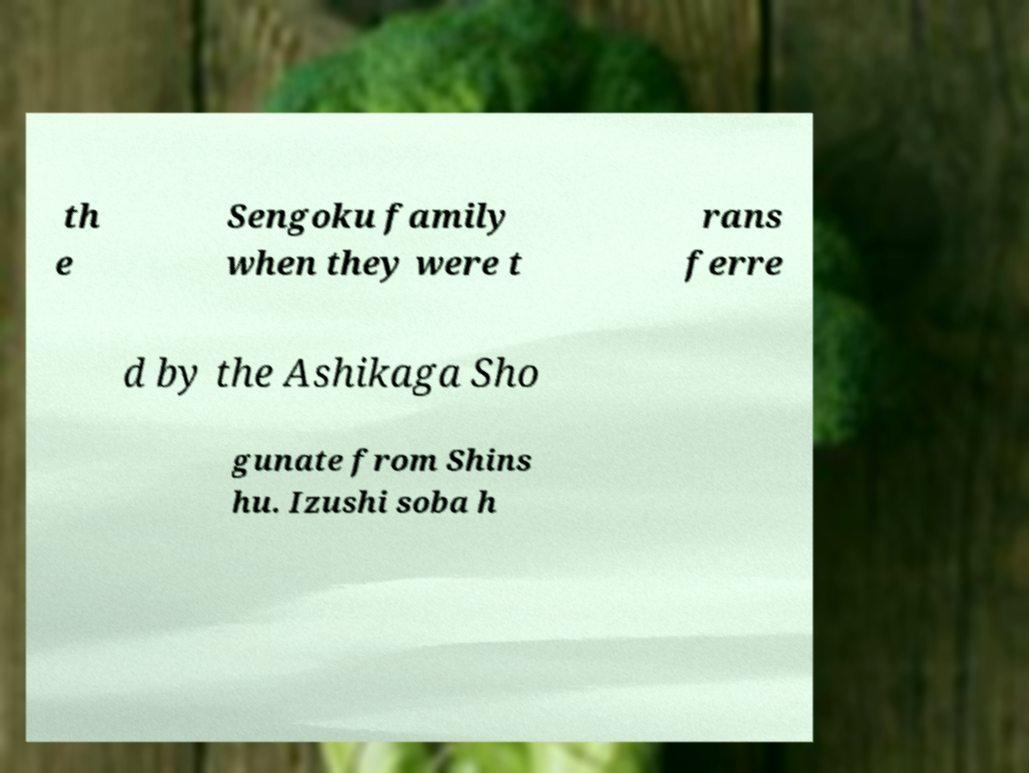Could you assist in decoding the text presented in this image and type it out clearly? th e Sengoku family when they were t rans ferre d by the Ashikaga Sho gunate from Shins hu. Izushi soba h 